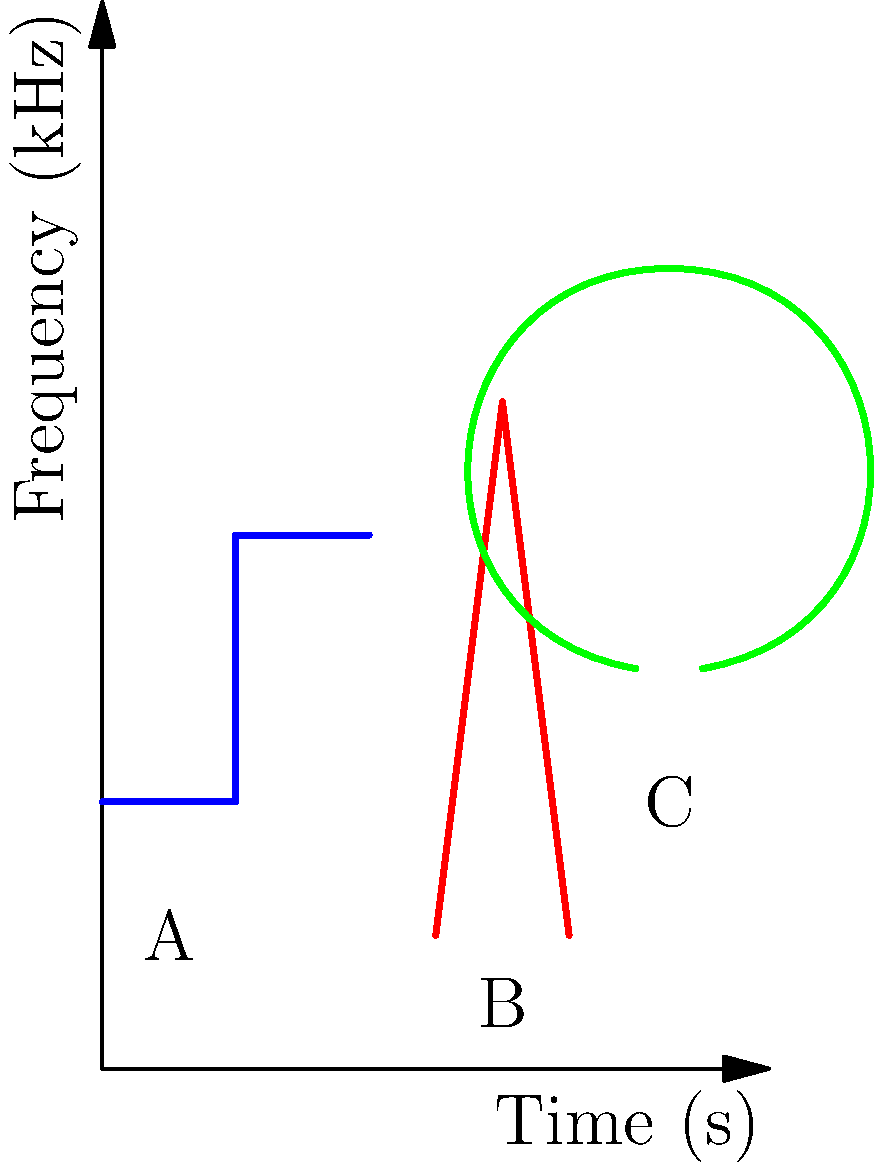Match the following bird songs to their corresponding spectrogram patterns shown in the image above:

1. American Robin
2. Black-capped Chickadee
3. Northern Cardinal To match the bird songs to their spectrogram patterns, we need to analyze the characteristics of each pattern and compare them to the typical vocalizations of the given bird species:

1. Pattern A (Blue): This shows a series of clear, steady whistles at a constant frequency. This is characteristic of the American Robin's song, which consists of a series of clear whistled phrases.

2. Pattern B (Red): This pattern shows a clear whistled "fee-bee" or "hey, sweetie" pattern, with a higher-pitched note followed by a lower one. This is typical of the Black-capped Chickadee's song.

3. Pattern C (Green): This shows a series of short, varied whistles that quickly change in pitch. This pattern is consistent with the Northern Cardinal's song, which is a series of clear, whistled phrases that vary in pitch and rhythm.

Therefore, the correct matches are:

A (Blue) - American Robin
B (Red) - Black-capped Chickadee
C (Green) - Northern Cardinal
Answer: A-1, B-2, C-3 